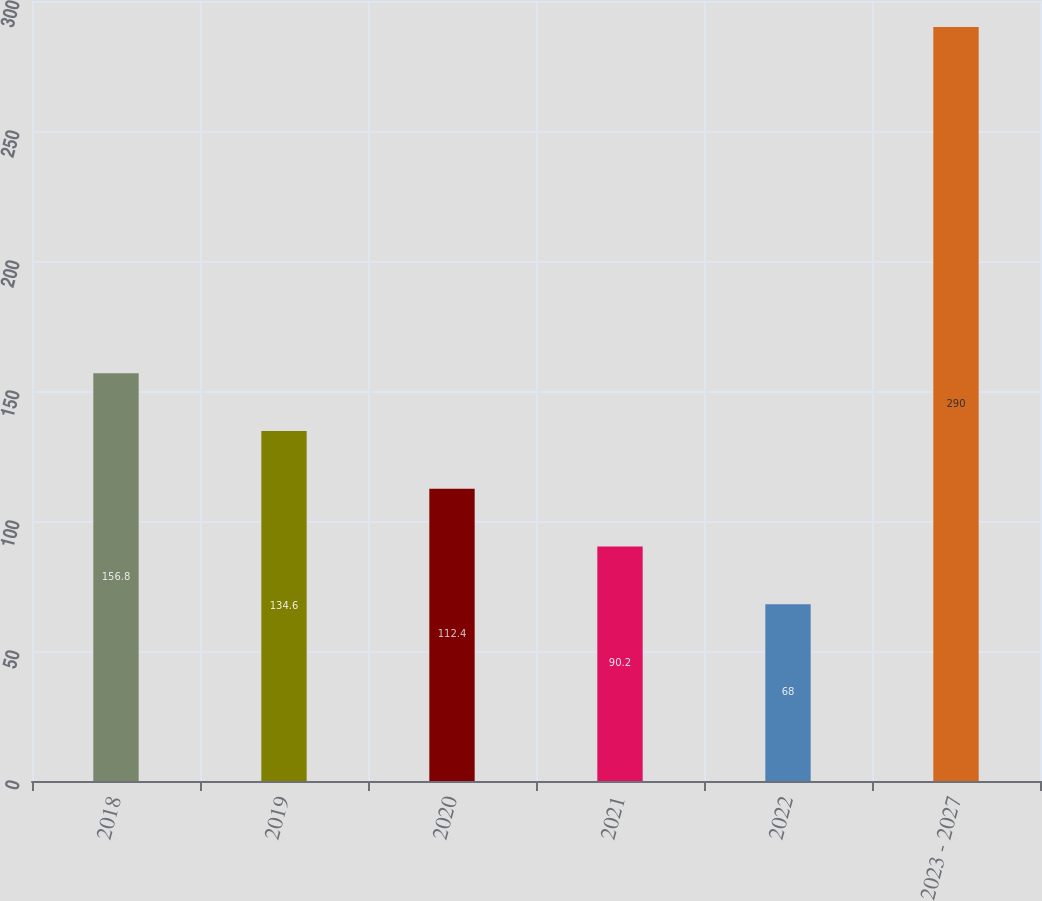Convert chart to OTSL. <chart><loc_0><loc_0><loc_500><loc_500><bar_chart><fcel>2018<fcel>2019<fcel>2020<fcel>2021<fcel>2022<fcel>2023 - 2027<nl><fcel>156.8<fcel>134.6<fcel>112.4<fcel>90.2<fcel>68<fcel>290<nl></chart> 